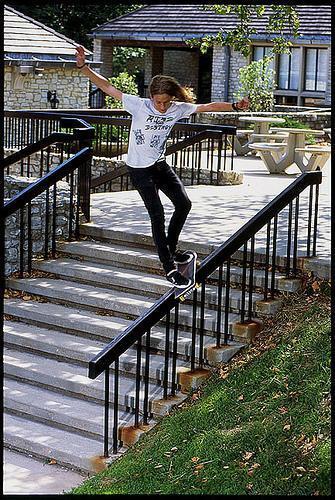How many steps are there?
Give a very brief answer. 9. 